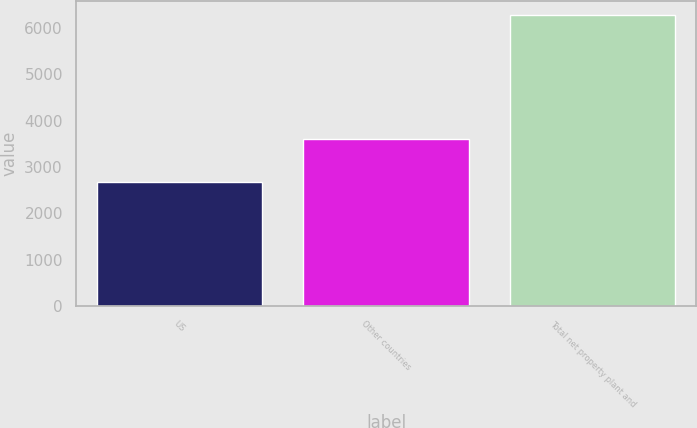Convert chart. <chart><loc_0><loc_0><loc_500><loc_500><bar_chart><fcel>US<fcel>Other countries<fcel>Total net property plant and<nl><fcel>2673<fcel>3596<fcel>6269<nl></chart> 